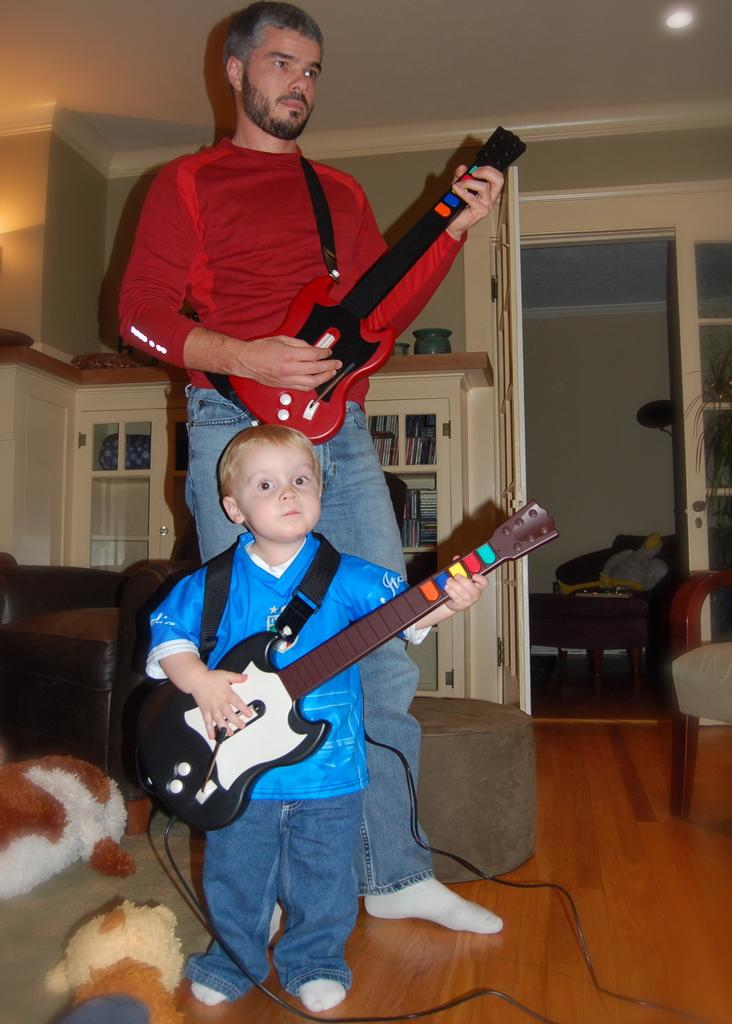Who or what can be seen in the image? There are people in the image. What are the people holding in their hands? The people are holding guitars in their hands. What time of day is it in the image? The time of day cannot be determined from the image, as there are no clues or indicators of the time. 